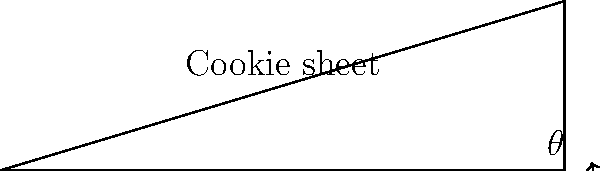When baking cookies for the president's granddaughter, you notice that tilting the cookie sheet slightly helps with even baking. If the cookie sheet is 10 inches long and you want to raise one end by 3 inches, what angle $\theta$ should you tilt the sheet to achieve this optimal position? To find the angle $\theta$, we can use basic trigonometry:

1. The cookie sheet forms a right triangle when tilted.
2. We know the length of the base (adjacent side) is 10 inches.
3. We know the height (opposite side) is 3 inches.
4. We need to find the angle $\theta$ between the base and the hypotenuse.
5. The tangent of an angle in a right triangle is the ratio of the opposite side to the adjacent side.
6. Therefore, $\tan(\theta) = \frac{\text{opposite}}{\text{adjacent}} = \frac{3}{10} = 0.3$
7. To find $\theta$, we take the inverse tangent (arctangent) of this ratio:
   $\theta = \tan^{-1}(0.3)$
8. Using a calculator or math library, we get:
   $\theta \approx 16.70^\circ$
Answer: $16.70^\circ$ 